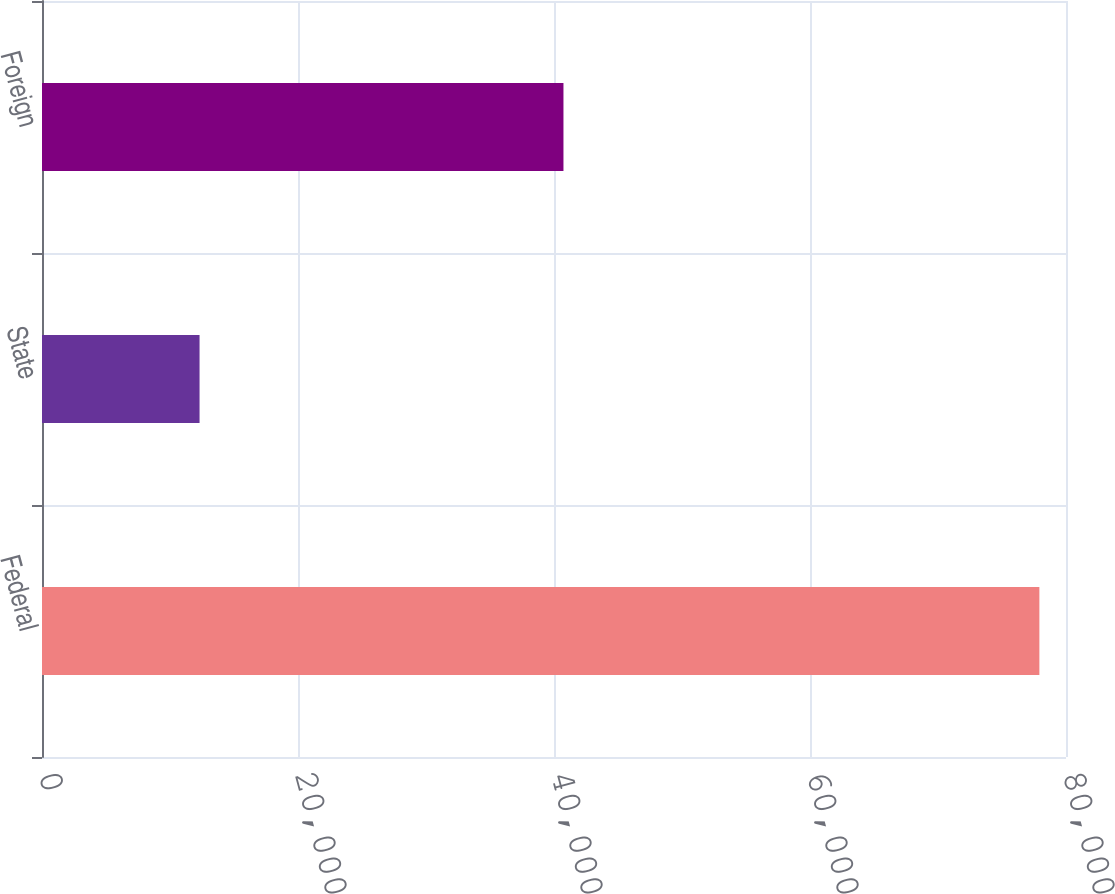Convert chart. <chart><loc_0><loc_0><loc_500><loc_500><bar_chart><fcel>Federal<fcel>State<fcel>Foreign<nl><fcel>77920<fcel>12309<fcel>40739<nl></chart> 